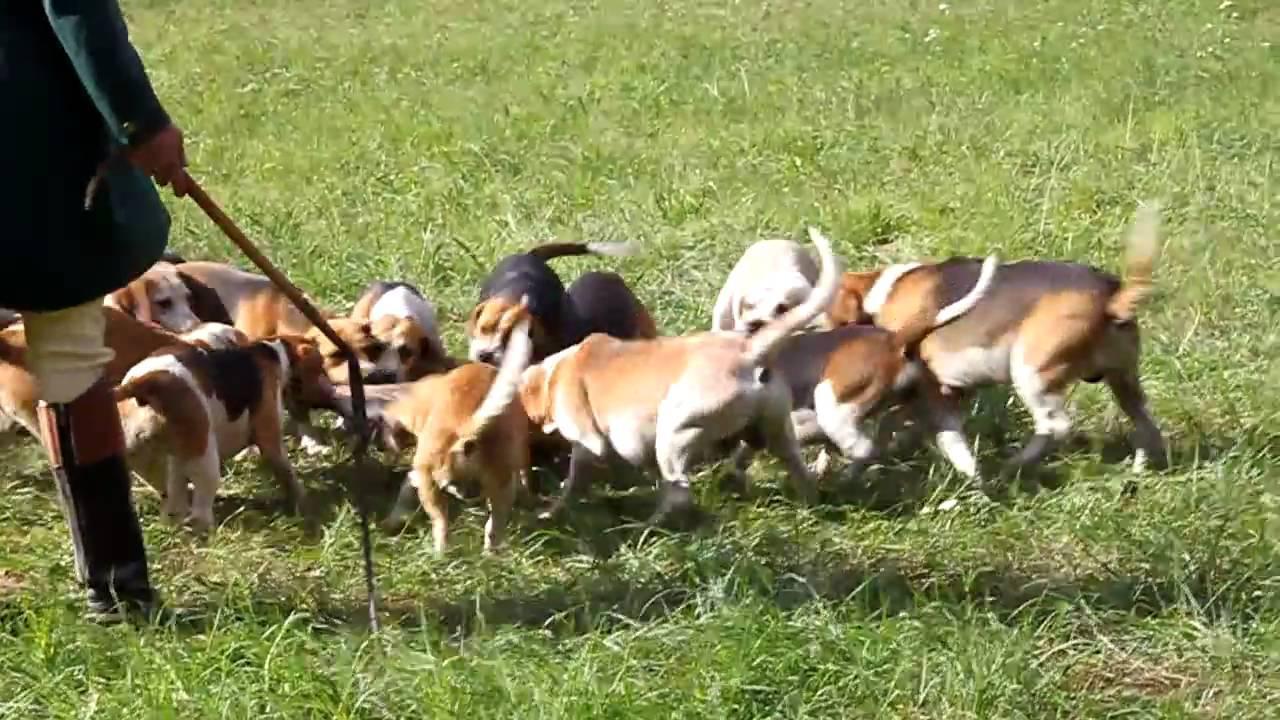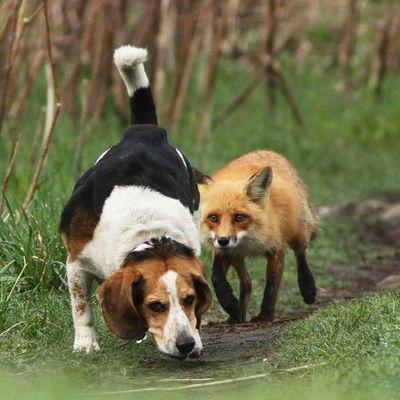The first image is the image on the left, the second image is the image on the right. For the images displayed, is the sentence "At least one human face is visible." factually correct? Answer yes or no. No. The first image is the image on the left, the second image is the image on the right. Given the left and right images, does the statement "Left image includes a person with a group of dogs." hold true? Answer yes or no. Yes. 